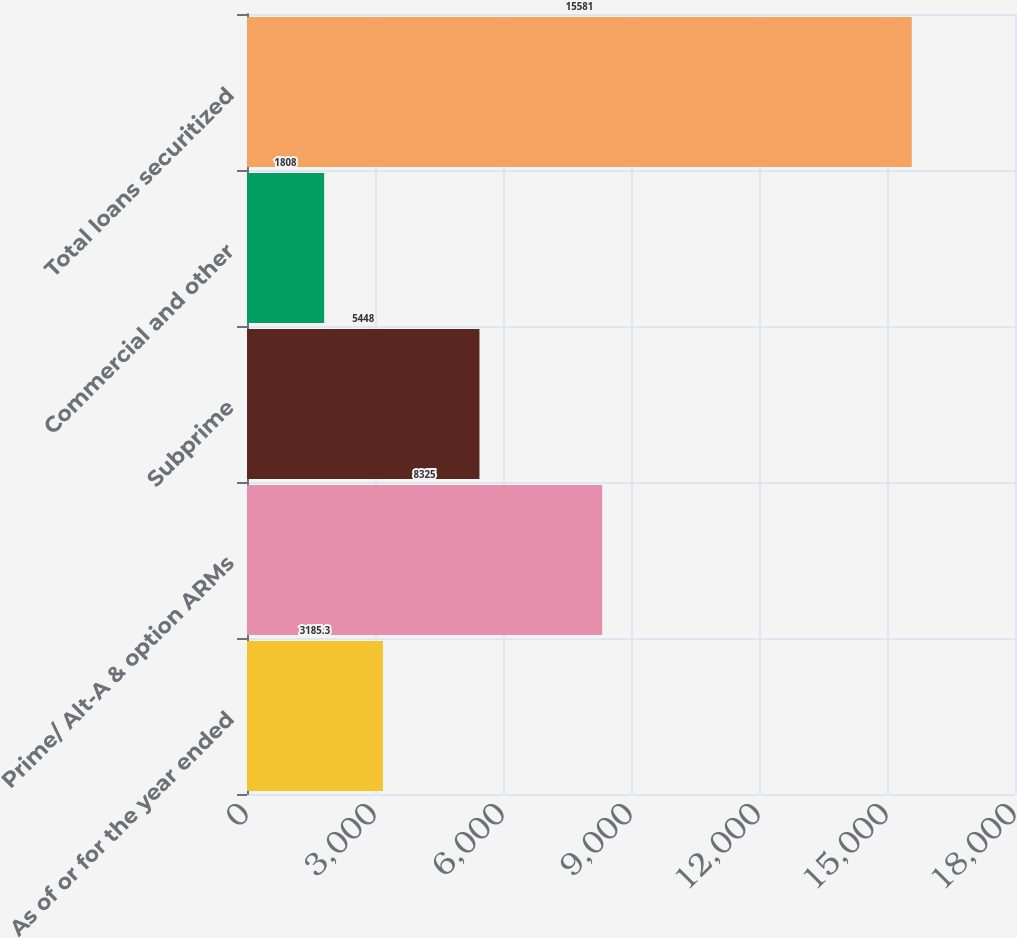<chart> <loc_0><loc_0><loc_500><loc_500><bar_chart><fcel>As of or for the year ended<fcel>Prime/ Alt-A & option ARMs<fcel>Subprime<fcel>Commercial and other<fcel>Total loans securitized<nl><fcel>3185.3<fcel>8325<fcel>5448<fcel>1808<fcel>15581<nl></chart> 